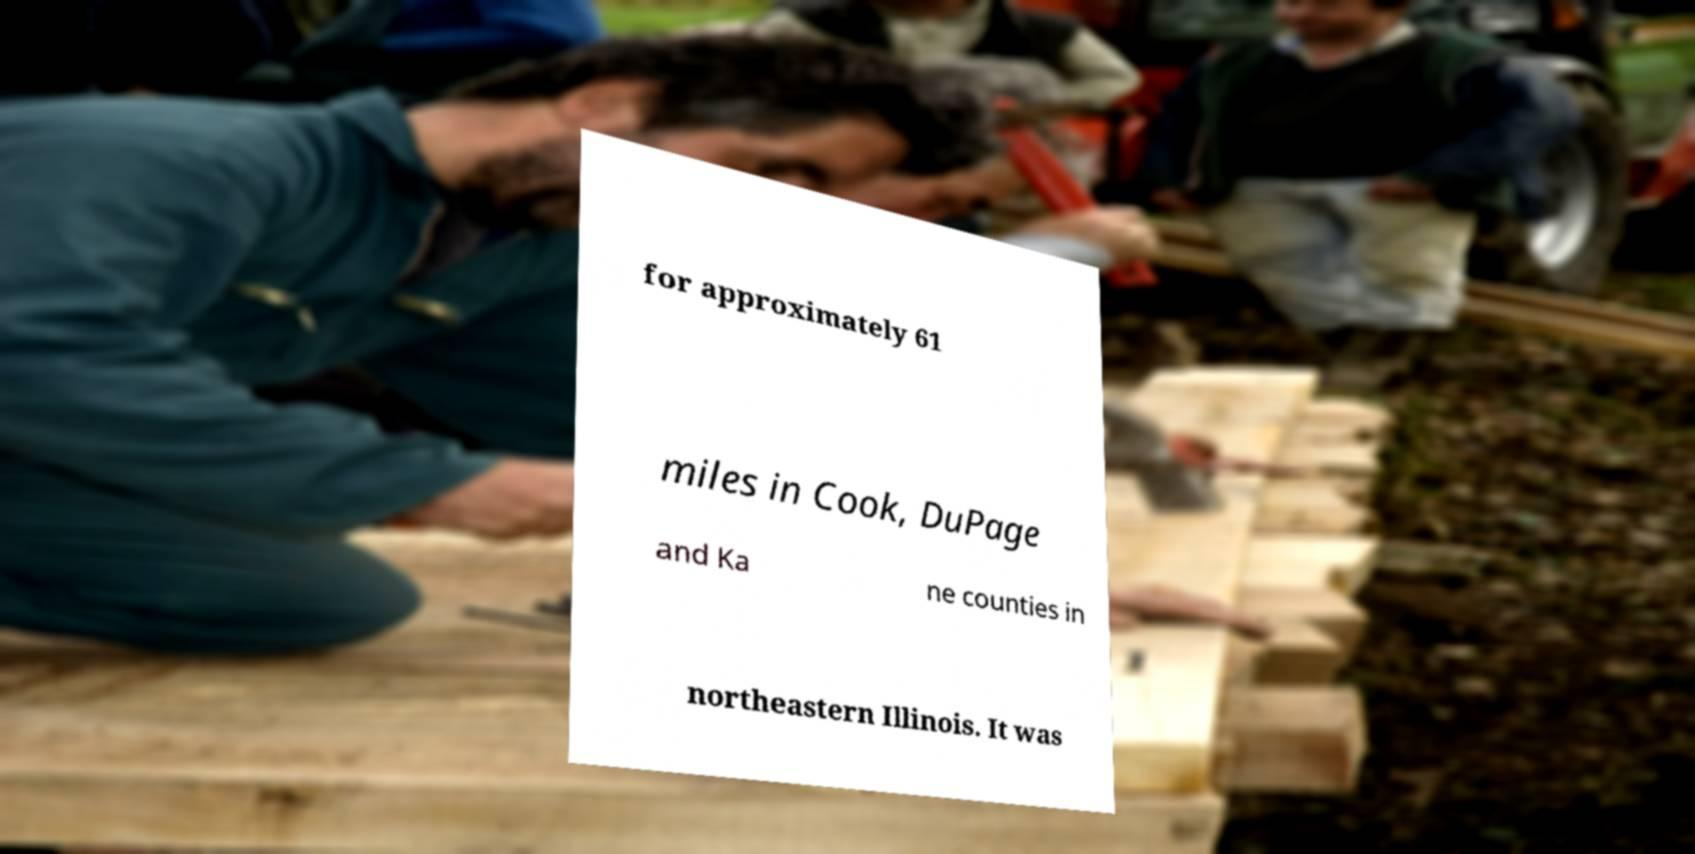Can you accurately transcribe the text from the provided image for me? for approximately 61 miles in Cook, DuPage and Ka ne counties in northeastern Illinois. It was 